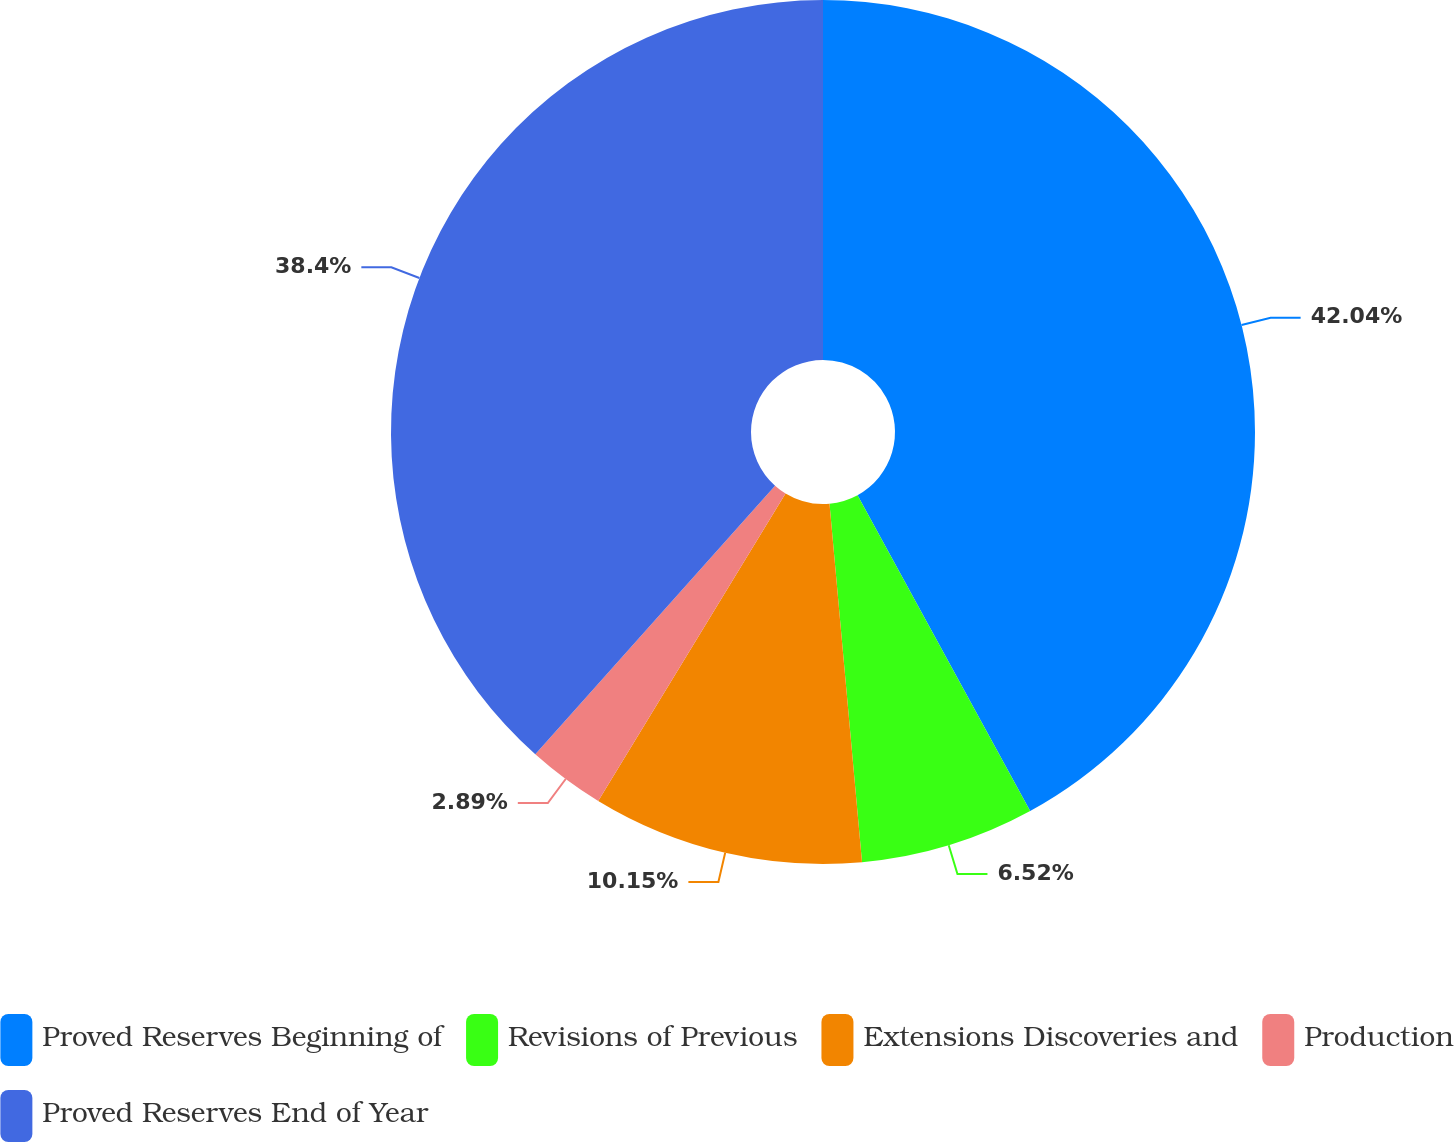Convert chart to OTSL. <chart><loc_0><loc_0><loc_500><loc_500><pie_chart><fcel>Proved Reserves Beginning of<fcel>Revisions of Previous<fcel>Extensions Discoveries and<fcel>Production<fcel>Proved Reserves End of Year<nl><fcel>42.04%<fcel>6.52%<fcel>10.15%<fcel>2.89%<fcel>38.4%<nl></chart> 